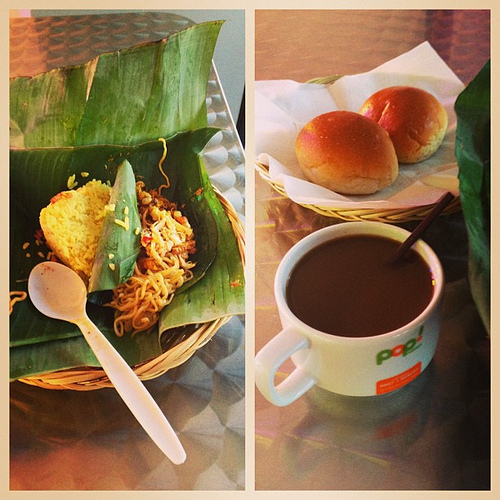The logo is on what? The logo is prominently displayed on the side of the white mug, standing out against the backdrop of the soothing drink it contains. 